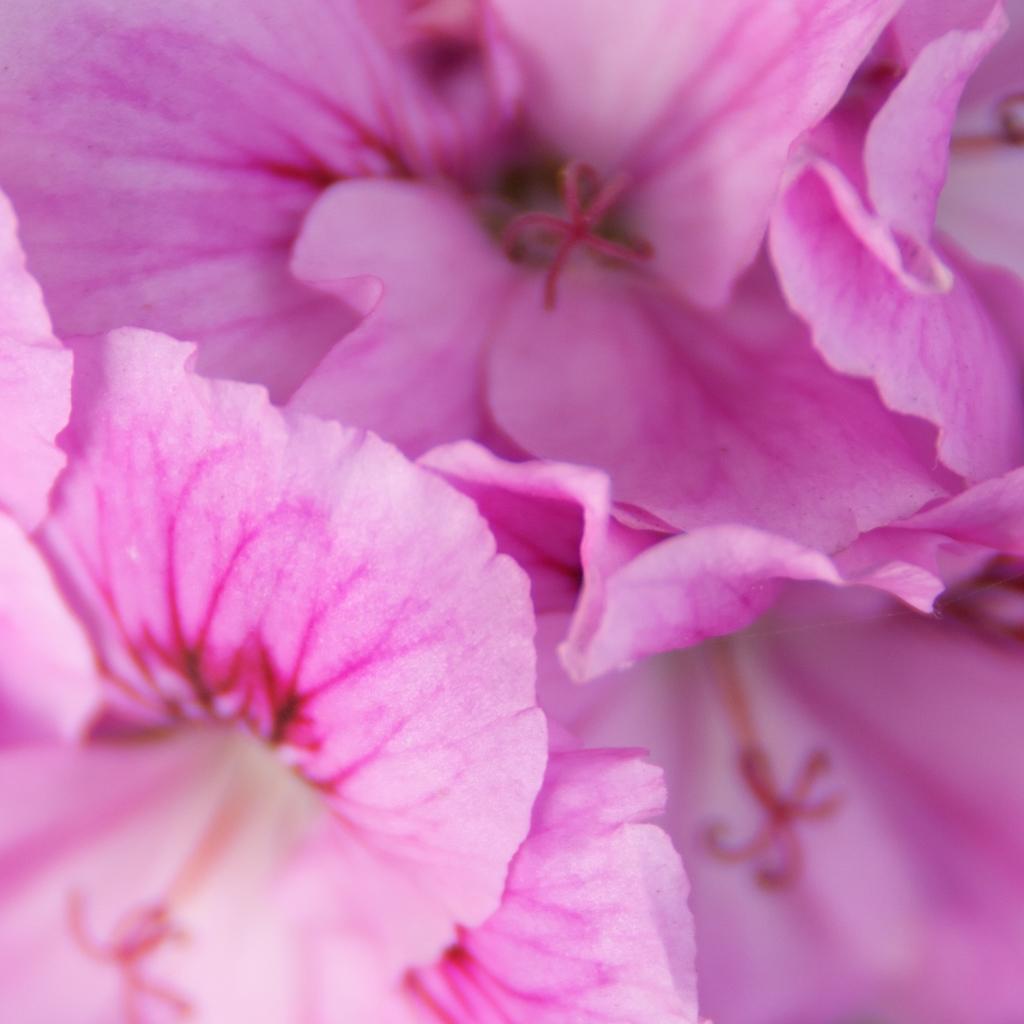Describe this image in one or two sentences. In this picture I can see flowers, pink in color. 